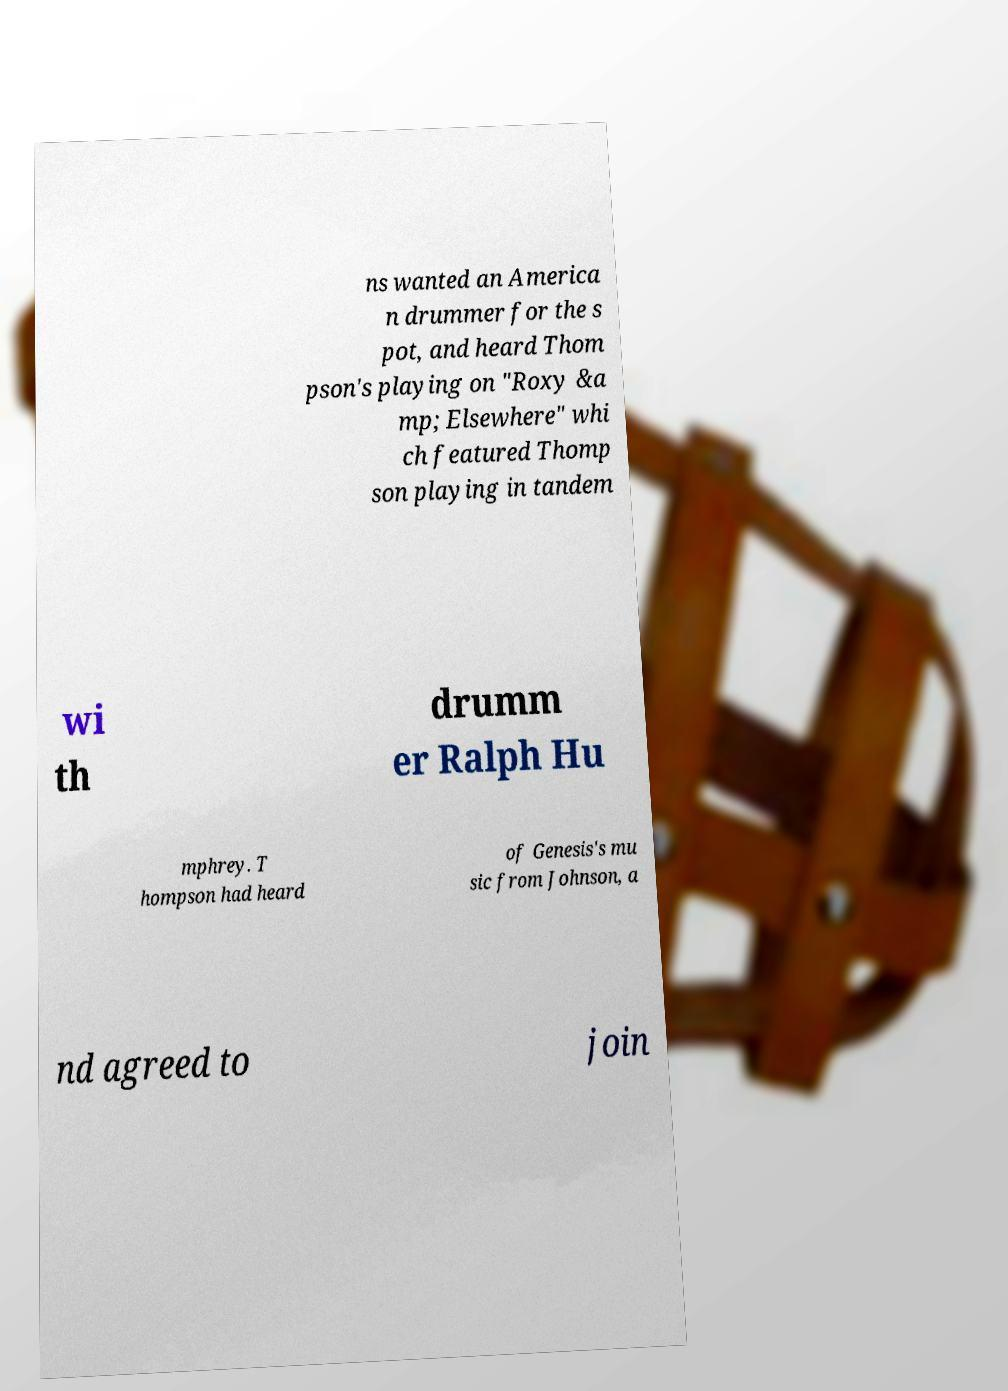Can you accurately transcribe the text from the provided image for me? ns wanted an America n drummer for the s pot, and heard Thom pson's playing on "Roxy &a mp; Elsewhere" whi ch featured Thomp son playing in tandem wi th drumm er Ralph Hu mphrey. T hompson had heard of Genesis's mu sic from Johnson, a nd agreed to join 